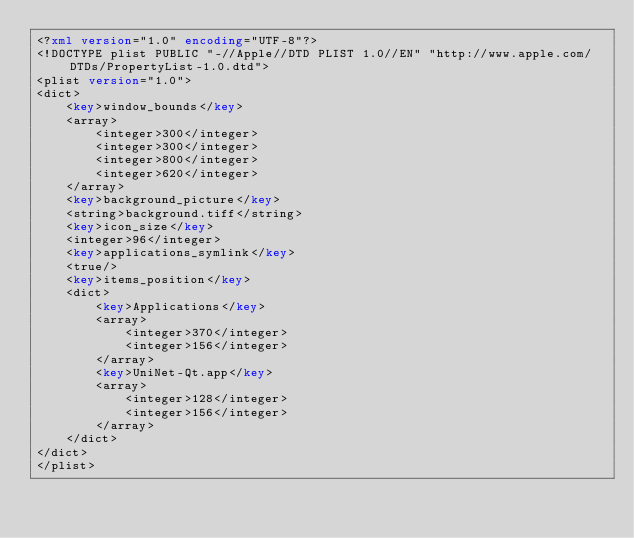Convert code to text. <code><loc_0><loc_0><loc_500><loc_500><_XML_><?xml version="1.0" encoding="UTF-8"?>
<!DOCTYPE plist PUBLIC "-//Apple//DTD PLIST 1.0//EN" "http://www.apple.com/DTDs/PropertyList-1.0.dtd">
<plist version="1.0">
<dict>
	<key>window_bounds</key>
	<array>
		<integer>300</integer>
		<integer>300</integer>
		<integer>800</integer>
		<integer>620</integer>
	</array>
	<key>background_picture</key>
	<string>background.tiff</string>
	<key>icon_size</key>
	<integer>96</integer>
	<key>applications_symlink</key>
	<true/>
	<key>items_position</key>
	<dict>
		<key>Applications</key>
		<array>
			<integer>370</integer>
			<integer>156</integer>
		</array>
		<key>UniNet-Qt.app</key>
		<array>
			<integer>128</integer>
			<integer>156</integer>
		</array>
	</dict>
</dict>
</plist>
</code> 